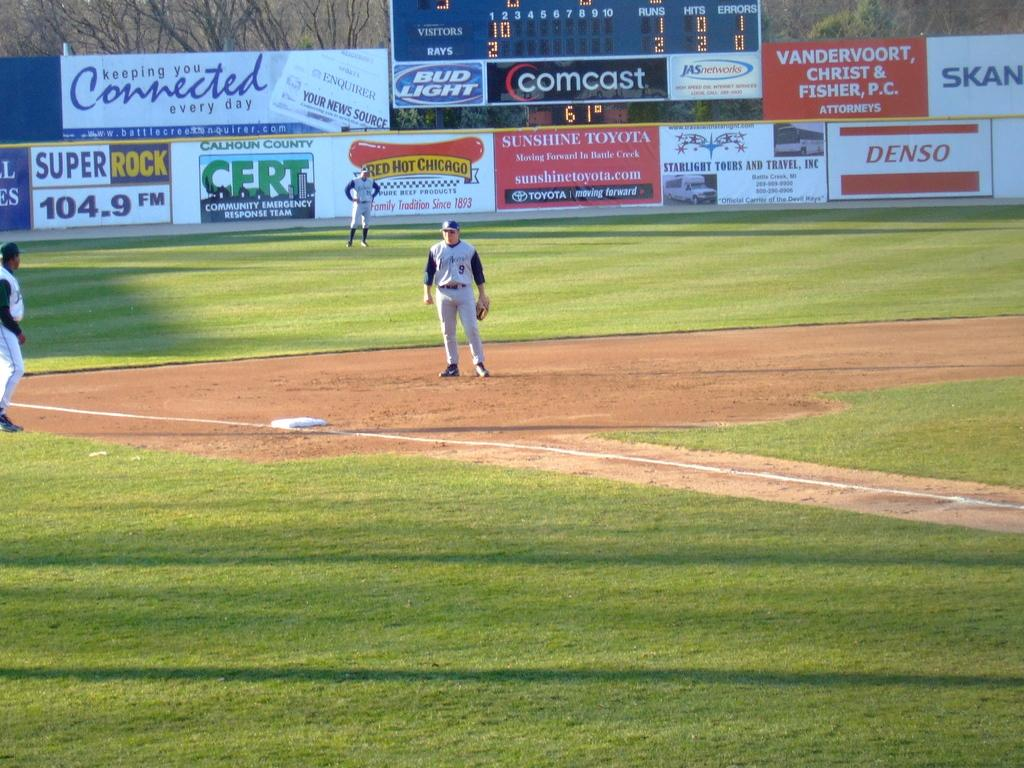Provide a one-sentence caption for the provided image. A minor league baseball field is filled with ads on the walls for things like CERT. 